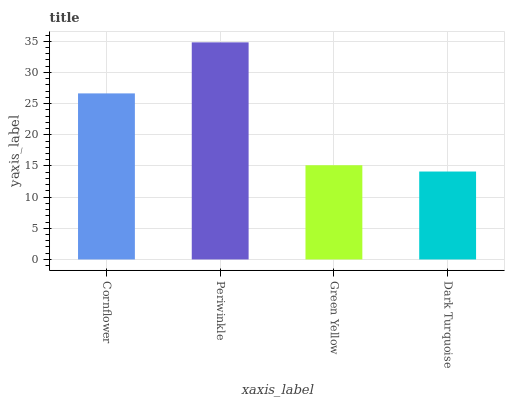Is Dark Turquoise the minimum?
Answer yes or no. Yes. Is Periwinkle the maximum?
Answer yes or no. Yes. Is Green Yellow the minimum?
Answer yes or no. No. Is Green Yellow the maximum?
Answer yes or no. No. Is Periwinkle greater than Green Yellow?
Answer yes or no. Yes. Is Green Yellow less than Periwinkle?
Answer yes or no. Yes. Is Green Yellow greater than Periwinkle?
Answer yes or no. No. Is Periwinkle less than Green Yellow?
Answer yes or no. No. Is Cornflower the high median?
Answer yes or no. Yes. Is Green Yellow the low median?
Answer yes or no. Yes. Is Green Yellow the high median?
Answer yes or no. No. Is Cornflower the low median?
Answer yes or no. No. 